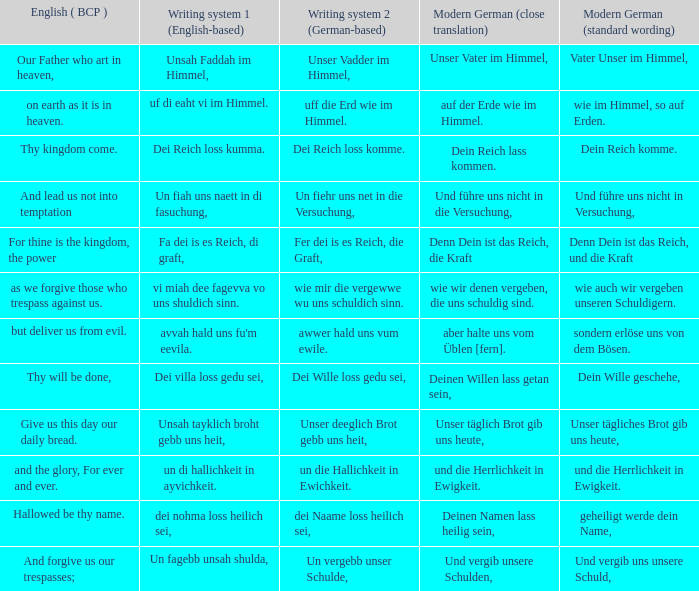What is the modern german standard wording for the german based writing system 2 phrase "wie mir die vergewwe wu uns schuldich sinn."? Wie auch wir vergeben unseren schuldigern. 